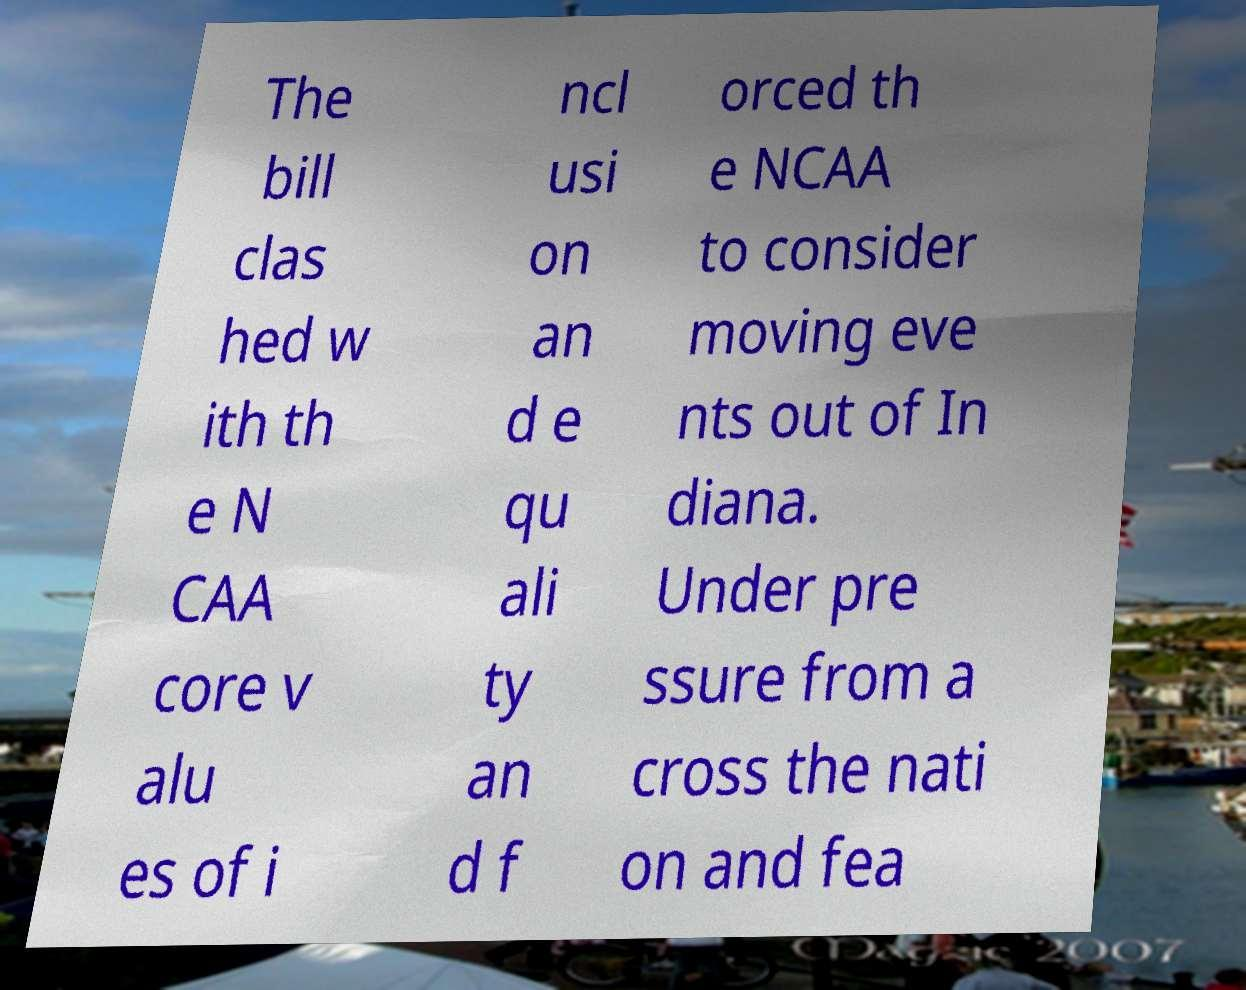For documentation purposes, I need the text within this image transcribed. Could you provide that? The bill clas hed w ith th e N CAA core v alu es of i ncl usi on an d e qu ali ty an d f orced th e NCAA to consider moving eve nts out of In diana. Under pre ssure from a cross the nati on and fea 